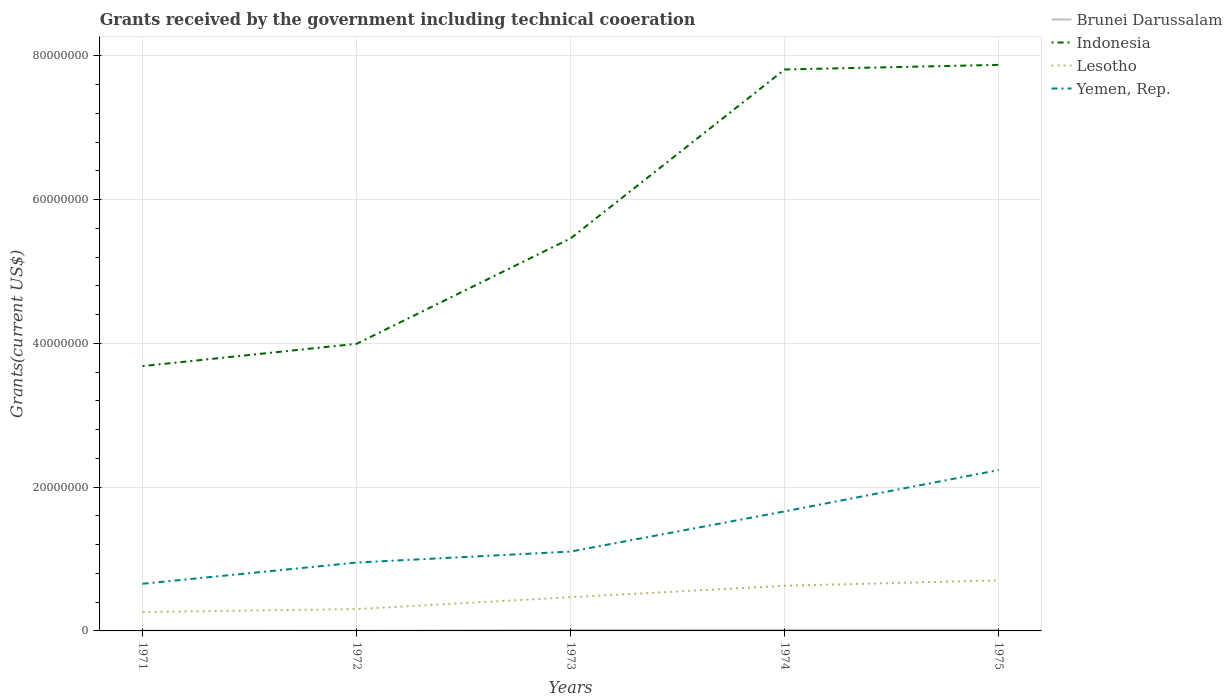How many different coloured lines are there?
Your response must be concise. 4. Does the line corresponding to Lesotho intersect with the line corresponding to Yemen, Rep.?
Provide a succinct answer. No. Is the number of lines equal to the number of legend labels?
Your answer should be compact. Yes. Across all years, what is the maximum total grants received by the government in Yemen, Rep.?
Provide a succinct answer. 6.56e+06. In which year was the total grants received by the government in Indonesia maximum?
Offer a terse response. 1971. What is the total total grants received by the government in Lesotho in the graph?
Your answer should be very brief. -3.24e+06. What is the difference between the highest and the second highest total grants received by the government in Lesotho?
Make the answer very short. 4.41e+06. What is the difference between the highest and the lowest total grants received by the government in Yemen, Rep.?
Ensure brevity in your answer.  2. How many lines are there?
Your answer should be very brief. 4. How many years are there in the graph?
Your answer should be compact. 5. Are the values on the major ticks of Y-axis written in scientific E-notation?
Offer a terse response. No. Does the graph contain any zero values?
Your response must be concise. No. Does the graph contain grids?
Your response must be concise. Yes. How are the legend labels stacked?
Offer a very short reply. Vertical. What is the title of the graph?
Provide a short and direct response. Grants received by the government including technical cooeration. Does "Malta" appear as one of the legend labels in the graph?
Your answer should be very brief. No. What is the label or title of the X-axis?
Offer a terse response. Years. What is the label or title of the Y-axis?
Offer a very short reply. Grants(current US$). What is the Grants(current US$) of Indonesia in 1971?
Ensure brevity in your answer.  3.68e+07. What is the Grants(current US$) of Lesotho in 1971?
Your answer should be very brief. 2.63e+06. What is the Grants(current US$) of Yemen, Rep. in 1971?
Keep it short and to the point. 6.56e+06. What is the Grants(current US$) in Indonesia in 1972?
Ensure brevity in your answer.  3.99e+07. What is the Grants(current US$) in Lesotho in 1972?
Make the answer very short. 3.04e+06. What is the Grants(current US$) in Yemen, Rep. in 1972?
Offer a very short reply. 9.51e+06. What is the Grants(current US$) of Brunei Darussalam in 1973?
Your response must be concise. 1.20e+05. What is the Grants(current US$) of Indonesia in 1973?
Offer a terse response. 5.46e+07. What is the Grants(current US$) in Lesotho in 1973?
Offer a terse response. 4.69e+06. What is the Grants(current US$) in Yemen, Rep. in 1973?
Your answer should be very brief. 1.10e+07. What is the Grants(current US$) in Brunei Darussalam in 1974?
Keep it short and to the point. 1.50e+05. What is the Grants(current US$) of Indonesia in 1974?
Your answer should be compact. 7.81e+07. What is the Grants(current US$) of Lesotho in 1974?
Provide a short and direct response. 6.28e+06. What is the Grants(current US$) in Yemen, Rep. in 1974?
Provide a short and direct response. 1.66e+07. What is the Grants(current US$) in Brunei Darussalam in 1975?
Offer a terse response. 1.40e+05. What is the Grants(current US$) in Indonesia in 1975?
Offer a terse response. 7.87e+07. What is the Grants(current US$) in Lesotho in 1975?
Provide a short and direct response. 7.04e+06. What is the Grants(current US$) of Yemen, Rep. in 1975?
Provide a short and direct response. 2.24e+07. Across all years, what is the maximum Grants(current US$) in Indonesia?
Provide a succinct answer. 7.87e+07. Across all years, what is the maximum Grants(current US$) of Lesotho?
Ensure brevity in your answer.  7.04e+06. Across all years, what is the maximum Grants(current US$) of Yemen, Rep.?
Your answer should be compact. 2.24e+07. Across all years, what is the minimum Grants(current US$) of Brunei Darussalam?
Offer a terse response. 2.00e+04. Across all years, what is the minimum Grants(current US$) in Indonesia?
Provide a succinct answer. 3.68e+07. Across all years, what is the minimum Grants(current US$) in Lesotho?
Keep it short and to the point. 2.63e+06. Across all years, what is the minimum Grants(current US$) of Yemen, Rep.?
Keep it short and to the point. 6.56e+06. What is the total Grants(current US$) in Indonesia in the graph?
Offer a very short reply. 2.88e+08. What is the total Grants(current US$) of Lesotho in the graph?
Your response must be concise. 2.37e+07. What is the total Grants(current US$) of Yemen, Rep. in the graph?
Offer a very short reply. 6.61e+07. What is the difference between the Grants(current US$) in Indonesia in 1971 and that in 1972?
Ensure brevity in your answer.  -3.10e+06. What is the difference between the Grants(current US$) in Lesotho in 1971 and that in 1972?
Provide a succinct answer. -4.10e+05. What is the difference between the Grants(current US$) in Yemen, Rep. in 1971 and that in 1972?
Your answer should be very brief. -2.95e+06. What is the difference between the Grants(current US$) in Indonesia in 1971 and that in 1973?
Your answer should be very brief. -1.78e+07. What is the difference between the Grants(current US$) of Lesotho in 1971 and that in 1973?
Your answer should be very brief. -2.06e+06. What is the difference between the Grants(current US$) in Yemen, Rep. in 1971 and that in 1973?
Give a very brief answer. -4.48e+06. What is the difference between the Grants(current US$) of Indonesia in 1971 and that in 1974?
Give a very brief answer. -4.13e+07. What is the difference between the Grants(current US$) in Lesotho in 1971 and that in 1974?
Offer a terse response. -3.65e+06. What is the difference between the Grants(current US$) of Yemen, Rep. in 1971 and that in 1974?
Provide a succinct answer. -1.01e+07. What is the difference between the Grants(current US$) in Indonesia in 1971 and that in 1975?
Your response must be concise. -4.19e+07. What is the difference between the Grants(current US$) of Lesotho in 1971 and that in 1975?
Give a very brief answer. -4.41e+06. What is the difference between the Grants(current US$) in Yemen, Rep. in 1971 and that in 1975?
Your answer should be very brief. -1.58e+07. What is the difference between the Grants(current US$) of Brunei Darussalam in 1972 and that in 1973?
Your answer should be very brief. -1.00e+05. What is the difference between the Grants(current US$) in Indonesia in 1972 and that in 1973?
Provide a short and direct response. -1.47e+07. What is the difference between the Grants(current US$) of Lesotho in 1972 and that in 1973?
Offer a terse response. -1.65e+06. What is the difference between the Grants(current US$) of Yemen, Rep. in 1972 and that in 1973?
Offer a terse response. -1.53e+06. What is the difference between the Grants(current US$) of Brunei Darussalam in 1972 and that in 1974?
Make the answer very short. -1.30e+05. What is the difference between the Grants(current US$) of Indonesia in 1972 and that in 1974?
Offer a very short reply. -3.82e+07. What is the difference between the Grants(current US$) of Lesotho in 1972 and that in 1974?
Provide a succinct answer. -3.24e+06. What is the difference between the Grants(current US$) in Yemen, Rep. in 1972 and that in 1974?
Give a very brief answer. -7.12e+06. What is the difference between the Grants(current US$) in Brunei Darussalam in 1972 and that in 1975?
Give a very brief answer. -1.20e+05. What is the difference between the Grants(current US$) of Indonesia in 1972 and that in 1975?
Your answer should be compact. -3.88e+07. What is the difference between the Grants(current US$) in Lesotho in 1972 and that in 1975?
Your response must be concise. -4.00e+06. What is the difference between the Grants(current US$) of Yemen, Rep. in 1972 and that in 1975?
Give a very brief answer. -1.29e+07. What is the difference between the Grants(current US$) in Indonesia in 1973 and that in 1974?
Your response must be concise. -2.35e+07. What is the difference between the Grants(current US$) of Lesotho in 1973 and that in 1974?
Make the answer very short. -1.59e+06. What is the difference between the Grants(current US$) of Yemen, Rep. in 1973 and that in 1974?
Provide a succinct answer. -5.59e+06. What is the difference between the Grants(current US$) in Indonesia in 1973 and that in 1975?
Offer a terse response. -2.41e+07. What is the difference between the Grants(current US$) in Lesotho in 1973 and that in 1975?
Provide a short and direct response. -2.35e+06. What is the difference between the Grants(current US$) of Yemen, Rep. in 1973 and that in 1975?
Provide a short and direct response. -1.13e+07. What is the difference between the Grants(current US$) in Indonesia in 1974 and that in 1975?
Your answer should be compact. -6.40e+05. What is the difference between the Grants(current US$) of Lesotho in 1974 and that in 1975?
Your answer should be compact. -7.60e+05. What is the difference between the Grants(current US$) of Yemen, Rep. in 1974 and that in 1975?
Offer a terse response. -5.75e+06. What is the difference between the Grants(current US$) of Brunei Darussalam in 1971 and the Grants(current US$) of Indonesia in 1972?
Keep it short and to the point. -3.99e+07. What is the difference between the Grants(current US$) of Brunei Darussalam in 1971 and the Grants(current US$) of Lesotho in 1972?
Provide a succinct answer. -2.99e+06. What is the difference between the Grants(current US$) in Brunei Darussalam in 1971 and the Grants(current US$) in Yemen, Rep. in 1972?
Your answer should be compact. -9.46e+06. What is the difference between the Grants(current US$) of Indonesia in 1971 and the Grants(current US$) of Lesotho in 1972?
Make the answer very short. 3.38e+07. What is the difference between the Grants(current US$) of Indonesia in 1971 and the Grants(current US$) of Yemen, Rep. in 1972?
Offer a terse response. 2.73e+07. What is the difference between the Grants(current US$) in Lesotho in 1971 and the Grants(current US$) in Yemen, Rep. in 1972?
Provide a short and direct response. -6.88e+06. What is the difference between the Grants(current US$) of Brunei Darussalam in 1971 and the Grants(current US$) of Indonesia in 1973?
Give a very brief answer. -5.46e+07. What is the difference between the Grants(current US$) of Brunei Darussalam in 1971 and the Grants(current US$) of Lesotho in 1973?
Your answer should be very brief. -4.64e+06. What is the difference between the Grants(current US$) in Brunei Darussalam in 1971 and the Grants(current US$) in Yemen, Rep. in 1973?
Keep it short and to the point. -1.10e+07. What is the difference between the Grants(current US$) of Indonesia in 1971 and the Grants(current US$) of Lesotho in 1973?
Offer a very short reply. 3.22e+07. What is the difference between the Grants(current US$) of Indonesia in 1971 and the Grants(current US$) of Yemen, Rep. in 1973?
Provide a short and direct response. 2.58e+07. What is the difference between the Grants(current US$) in Lesotho in 1971 and the Grants(current US$) in Yemen, Rep. in 1973?
Provide a succinct answer. -8.41e+06. What is the difference between the Grants(current US$) in Brunei Darussalam in 1971 and the Grants(current US$) in Indonesia in 1974?
Your answer should be very brief. -7.80e+07. What is the difference between the Grants(current US$) in Brunei Darussalam in 1971 and the Grants(current US$) in Lesotho in 1974?
Give a very brief answer. -6.23e+06. What is the difference between the Grants(current US$) of Brunei Darussalam in 1971 and the Grants(current US$) of Yemen, Rep. in 1974?
Your answer should be compact. -1.66e+07. What is the difference between the Grants(current US$) of Indonesia in 1971 and the Grants(current US$) of Lesotho in 1974?
Make the answer very short. 3.06e+07. What is the difference between the Grants(current US$) of Indonesia in 1971 and the Grants(current US$) of Yemen, Rep. in 1974?
Offer a very short reply. 2.02e+07. What is the difference between the Grants(current US$) of Lesotho in 1971 and the Grants(current US$) of Yemen, Rep. in 1974?
Your answer should be compact. -1.40e+07. What is the difference between the Grants(current US$) in Brunei Darussalam in 1971 and the Grants(current US$) in Indonesia in 1975?
Keep it short and to the point. -7.87e+07. What is the difference between the Grants(current US$) in Brunei Darussalam in 1971 and the Grants(current US$) in Lesotho in 1975?
Your answer should be compact. -6.99e+06. What is the difference between the Grants(current US$) of Brunei Darussalam in 1971 and the Grants(current US$) of Yemen, Rep. in 1975?
Give a very brief answer. -2.23e+07. What is the difference between the Grants(current US$) of Indonesia in 1971 and the Grants(current US$) of Lesotho in 1975?
Your response must be concise. 2.98e+07. What is the difference between the Grants(current US$) in Indonesia in 1971 and the Grants(current US$) in Yemen, Rep. in 1975?
Provide a short and direct response. 1.45e+07. What is the difference between the Grants(current US$) of Lesotho in 1971 and the Grants(current US$) of Yemen, Rep. in 1975?
Your answer should be very brief. -1.98e+07. What is the difference between the Grants(current US$) in Brunei Darussalam in 1972 and the Grants(current US$) in Indonesia in 1973?
Offer a very short reply. -5.46e+07. What is the difference between the Grants(current US$) in Brunei Darussalam in 1972 and the Grants(current US$) in Lesotho in 1973?
Your answer should be very brief. -4.67e+06. What is the difference between the Grants(current US$) in Brunei Darussalam in 1972 and the Grants(current US$) in Yemen, Rep. in 1973?
Offer a terse response. -1.10e+07. What is the difference between the Grants(current US$) of Indonesia in 1972 and the Grants(current US$) of Lesotho in 1973?
Your answer should be very brief. 3.52e+07. What is the difference between the Grants(current US$) of Indonesia in 1972 and the Grants(current US$) of Yemen, Rep. in 1973?
Make the answer very short. 2.89e+07. What is the difference between the Grants(current US$) in Lesotho in 1972 and the Grants(current US$) in Yemen, Rep. in 1973?
Offer a terse response. -8.00e+06. What is the difference between the Grants(current US$) of Brunei Darussalam in 1972 and the Grants(current US$) of Indonesia in 1974?
Your answer should be very brief. -7.81e+07. What is the difference between the Grants(current US$) in Brunei Darussalam in 1972 and the Grants(current US$) in Lesotho in 1974?
Your response must be concise. -6.26e+06. What is the difference between the Grants(current US$) in Brunei Darussalam in 1972 and the Grants(current US$) in Yemen, Rep. in 1974?
Keep it short and to the point. -1.66e+07. What is the difference between the Grants(current US$) in Indonesia in 1972 and the Grants(current US$) in Lesotho in 1974?
Provide a short and direct response. 3.37e+07. What is the difference between the Grants(current US$) of Indonesia in 1972 and the Grants(current US$) of Yemen, Rep. in 1974?
Offer a very short reply. 2.33e+07. What is the difference between the Grants(current US$) in Lesotho in 1972 and the Grants(current US$) in Yemen, Rep. in 1974?
Ensure brevity in your answer.  -1.36e+07. What is the difference between the Grants(current US$) of Brunei Darussalam in 1972 and the Grants(current US$) of Indonesia in 1975?
Your answer should be compact. -7.87e+07. What is the difference between the Grants(current US$) in Brunei Darussalam in 1972 and the Grants(current US$) in Lesotho in 1975?
Offer a terse response. -7.02e+06. What is the difference between the Grants(current US$) of Brunei Darussalam in 1972 and the Grants(current US$) of Yemen, Rep. in 1975?
Offer a very short reply. -2.24e+07. What is the difference between the Grants(current US$) of Indonesia in 1972 and the Grants(current US$) of Lesotho in 1975?
Your answer should be very brief. 3.29e+07. What is the difference between the Grants(current US$) in Indonesia in 1972 and the Grants(current US$) in Yemen, Rep. in 1975?
Your answer should be compact. 1.76e+07. What is the difference between the Grants(current US$) in Lesotho in 1972 and the Grants(current US$) in Yemen, Rep. in 1975?
Offer a very short reply. -1.93e+07. What is the difference between the Grants(current US$) in Brunei Darussalam in 1973 and the Grants(current US$) in Indonesia in 1974?
Give a very brief answer. -7.80e+07. What is the difference between the Grants(current US$) of Brunei Darussalam in 1973 and the Grants(current US$) of Lesotho in 1974?
Keep it short and to the point. -6.16e+06. What is the difference between the Grants(current US$) in Brunei Darussalam in 1973 and the Grants(current US$) in Yemen, Rep. in 1974?
Give a very brief answer. -1.65e+07. What is the difference between the Grants(current US$) in Indonesia in 1973 and the Grants(current US$) in Lesotho in 1974?
Your answer should be compact. 4.83e+07. What is the difference between the Grants(current US$) in Indonesia in 1973 and the Grants(current US$) in Yemen, Rep. in 1974?
Give a very brief answer. 3.80e+07. What is the difference between the Grants(current US$) of Lesotho in 1973 and the Grants(current US$) of Yemen, Rep. in 1974?
Ensure brevity in your answer.  -1.19e+07. What is the difference between the Grants(current US$) of Brunei Darussalam in 1973 and the Grants(current US$) of Indonesia in 1975?
Provide a succinct answer. -7.86e+07. What is the difference between the Grants(current US$) of Brunei Darussalam in 1973 and the Grants(current US$) of Lesotho in 1975?
Provide a short and direct response. -6.92e+06. What is the difference between the Grants(current US$) of Brunei Darussalam in 1973 and the Grants(current US$) of Yemen, Rep. in 1975?
Your answer should be compact. -2.23e+07. What is the difference between the Grants(current US$) of Indonesia in 1973 and the Grants(current US$) of Lesotho in 1975?
Keep it short and to the point. 4.76e+07. What is the difference between the Grants(current US$) of Indonesia in 1973 and the Grants(current US$) of Yemen, Rep. in 1975?
Give a very brief answer. 3.22e+07. What is the difference between the Grants(current US$) of Lesotho in 1973 and the Grants(current US$) of Yemen, Rep. in 1975?
Your response must be concise. -1.77e+07. What is the difference between the Grants(current US$) in Brunei Darussalam in 1974 and the Grants(current US$) in Indonesia in 1975?
Give a very brief answer. -7.86e+07. What is the difference between the Grants(current US$) in Brunei Darussalam in 1974 and the Grants(current US$) in Lesotho in 1975?
Provide a succinct answer. -6.89e+06. What is the difference between the Grants(current US$) in Brunei Darussalam in 1974 and the Grants(current US$) in Yemen, Rep. in 1975?
Provide a succinct answer. -2.22e+07. What is the difference between the Grants(current US$) of Indonesia in 1974 and the Grants(current US$) of Lesotho in 1975?
Keep it short and to the point. 7.11e+07. What is the difference between the Grants(current US$) in Indonesia in 1974 and the Grants(current US$) in Yemen, Rep. in 1975?
Your answer should be very brief. 5.57e+07. What is the difference between the Grants(current US$) of Lesotho in 1974 and the Grants(current US$) of Yemen, Rep. in 1975?
Provide a succinct answer. -1.61e+07. What is the average Grants(current US$) in Brunei Darussalam per year?
Provide a short and direct response. 9.60e+04. What is the average Grants(current US$) of Indonesia per year?
Make the answer very short. 5.76e+07. What is the average Grants(current US$) in Lesotho per year?
Give a very brief answer. 4.74e+06. What is the average Grants(current US$) in Yemen, Rep. per year?
Provide a succinct answer. 1.32e+07. In the year 1971, what is the difference between the Grants(current US$) in Brunei Darussalam and Grants(current US$) in Indonesia?
Provide a short and direct response. -3.68e+07. In the year 1971, what is the difference between the Grants(current US$) in Brunei Darussalam and Grants(current US$) in Lesotho?
Your response must be concise. -2.58e+06. In the year 1971, what is the difference between the Grants(current US$) of Brunei Darussalam and Grants(current US$) of Yemen, Rep.?
Your answer should be very brief. -6.51e+06. In the year 1971, what is the difference between the Grants(current US$) in Indonesia and Grants(current US$) in Lesotho?
Your response must be concise. 3.42e+07. In the year 1971, what is the difference between the Grants(current US$) of Indonesia and Grants(current US$) of Yemen, Rep.?
Your answer should be very brief. 3.03e+07. In the year 1971, what is the difference between the Grants(current US$) in Lesotho and Grants(current US$) in Yemen, Rep.?
Make the answer very short. -3.93e+06. In the year 1972, what is the difference between the Grants(current US$) in Brunei Darussalam and Grants(current US$) in Indonesia?
Give a very brief answer. -3.99e+07. In the year 1972, what is the difference between the Grants(current US$) in Brunei Darussalam and Grants(current US$) in Lesotho?
Provide a succinct answer. -3.02e+06. In the year 1972, what is the difference between the Grants(current US$) of Brunei Darussalam and Grants(current US$) of Yemen, Rep.?
Provide a short and direct response. -9.49e+06. In the year 1972, what is the difference between the Grants(current US$) of Indonesia and Grants(current US$) of Lesotho?
Your answer should be very brief. 3.69e+07. In the year 1972, what is the difference between the Grants(current US$) of Indonesia and Grants(current US$) of Yemen, Rep.?
Your answer should be compact. 3.04e+07. In the year 1972, what is the difference between the Grants(current US$) of Lesotho and Grants(current US$) of Yemen, Rep.?
Your answer should be very brief. -6.47e+06. In the year 1973, what is the difference between the Grants(current US$) of Brunei Darussalam and Grants(current US$) of Indonesia?
Make the answer very short. -5.45e+07. In the year 1973, what is the difference between the Grants(current US$) in Brunei Darussalam and Grants(current US$) in Lesotho?
Provide a succinct answer. -4.57e+06. In the year 1973, what is the difference between the Grants(current US$) of Brunei Darussalam and Grants(current US$) of Yemen, Rep.?
Provide a succinct answer. -1.09e+07. In the year 1973, what is the difference between the Grants(current US$) of Indonesia and Grants(current US$) of Lesotho?
Your response must be concise. 4.99e+07. In the year 1973, what is the difference between the Grants(current US$) of Indonesia and Grants(current US$) of Yemen, Rep.?
Make the answer very short. 4.36e+07. In the year 1973, what is the difference between the Grants(current US$) in Lesotho and Grants(current US$) in Yemen, Rep.?
Make the answer very short. -6.35e+06. In the year 1974, what is the difference between the Grants(current US$) in Brunei Darussalam and Grants(current US$) in Indonesia?
Give a very brief answer. -7.80e+07. In the year 1974, what is the difference between the Grants(current US$) of Brunei Darussalam and Grants(current US$) of Lesotho?
Provide a succinct answer. -6.13e+06. In the year 1974, what is the difference between the Grants(current US$) of Brunei Darussalam and Grants(current US$) of Yemen, Rep.?
Provide a short and direct response. -1.65e+07. In the year 1974, what is the difference between the Grants(current US$) in Indonesia and Grants(current US$) in Lesotho?
Keep it short and to the point. 7.18e+07. In the year 1974, what is the difference between the Grants(current US$) of Indonesia and Grants(current US$) of Yemen, Rep.?
Provide a short and direct response. 6.15e+07. In the year 1974, what is the difference between the Grants(current US$) in Lesotho and Grants(current US$) in Yemen, Rep.?
Your response must be concise. -1.04e+07. In the year 1975, what is the difference between the Grants(current US$) in Brunei Darussalam and Grants(current US$) in Indonesia?
Offer a very short reply. -7.86e+07. In the year 1975, what is the difference between the Grants(current US$) in Brunei Darussalam and Grants(current US$) in Lesotho?
Keep it short and to the point. -6.90e+06. In the year 1975, what is the difference between the Grants(current US$) in Brunei Darussalam and Grants(current US$) in Yemen, Rep.?
Provide a short and direct response. -2.22e+07. In the year 1975, what is the difference between the Grants(current US$) in Indonesia and Grants(current US$) in Lesotho?
Offer a terse response. 7.17e+07. In the year 1975, what is the difference between the Grants(current US$) in Indonesia and Grants(current US$) in Yemen, Rep.?
Ensure brevity in your answer.  5.64e+07. In the year 1975, what is the difference between the Grants(current US$) of Lesotho and Grants(current US$) of Yemen, Rep.?
Offer a terse response. -1.53e+07. What is the ratio of the Grants(current US$) in Brunei Darussalam in 1971 to that in 1972?
Make the answer very short. 2.5. What is the ratio of the Grants(current US$) in Indonesia in 1971 to that in 1972?
Make the answer very short. 0.92. What is the ratio of the Grants(current US$) of Lesotho in 1971 to that in 1972?
Keep it short and to the point. 0.87. What is the ratio of the Grants(current US$) in Yemen, Rep. in 1971 to that in 1972?
Keep it short and to the point. 0.69. What is the ratio of the Grants(current US$) of Brunei Darussalam in 1971 to that in 1973?
Your answer should be compact. 0.42. What is the ratio of the Grants(current US$) in Indonesia in 1971 to that in 1973?
Offer a terse response. 0.67. What is the ratio of the Grants(current US$) of Lesotho in 1971 to that in 1973?
Make the answer very short. 0.56. What is the ratio of the Grants(current US$) in Yemen, Rep. in 1971 to that in 1973?
Give a very brief answer. 0.59. What is the ratio of the Grants(current US$) in Indonesia in 1971 to that in 1974?
Your answer should be compact. 0.47. What is the ratio of the Grants(current US$) of Lesotho in 1971 to that in 1974?
Your answer should be very brief. 0.42. What is the ratio of the Grants(current US$) in Yemen, Rep. in 1971 to that in 1974?
Your response must be concise. 0.39. What is the ratio of the Grants(current US$) in Brunei Darussalam in 1971 to that in 1975?
Keep it short and to the point. 0.36. What is the ratio of the Grants(current US$) of Indonesia in 1971 to that in 1975?
Your response must be concise. 0.47. What is the ratio of the Grants(current US$) of Lesotho in 1971 to that in 1975?
Give a very brief answer. 0.37. What is the ratio of the Grants(current US$) of Yemen, Rep. in 1971 to that in 1975?
Your answer should be compact. 0.29. What is the ratio of the Grants(current US$) of Indonesia in 1972 to that in 1973?
Provide a succinct answer. 0.73. What is the ratio of the Grants(current US$) of Lesotho in 1972 to that in 1973?
Provide a succinct answer. 0.65. What is the ratio of the Grants(current US$) in Yemen, Rep. in 1972 to that in 1973?
Provide a short and direct response. 0.86. What is the ratio of the Grants(current US$) of Brunei Darussalam in 1972 to that in 1974?
Give a very brief answer. 0.13. What is the ratio of the Grants(current US$) of Indonesia in 1972 to that in 1974?
Offer a very short reply. 0.51. What is the ratio of the Grants(current US$) of Lesotho in 1972 to that in 1974?
Keep it short and to the point. 0.48. What is the ratio of the Grants(current US$) in Yemen, Rep. in 1972 to that in 1974?
Give a very brief answer. 0.57. What is the ratio of the Grants(current US$) in Brunei Darussalam in 1972 to that in 1975?
Provide a short and direct response. 0.14. What is the ratio of the Grants(current US$) in Indonesia in 1972 to that in 1975?
Provide a succinct answer. 0.51. What is the ratio of the Grants(current US$) of Lesotho in 1972 to that in 1975?
Provide a short and direct response. 0.43. What is the ratio of the Grants(current US$) in Yemen, Rep. in 1972 to that in 1975?
Your answer should be very brief. 0.42. What is the ratio of the Grants(current US$) of Indonesia in 1973 to that in 1974?
Your answer should be compact. 0.7. What is the ratio of the Grants(current US$) of Lesotho in 1973 to that in 1974?
Give a very brief answer. 0.75. What is the ratio of the Grants(current US$) of Yemen, Rep. in 1973 to that in 1974?
Ensure brevity in your answer.  0.66. What is the ratio of the Grants(current US$) in Brunei Darussalam in 1973 to that in 1975?
Your response must be concise. 0.86. What is the ratio of the Grants(current US$) of Indonesia in 1973 to that in 1975?
Your answer should be compact. 0.69. What is the ratio of the Grants(current US$) in Lesotho in 1973 to that in 1975?
Make the answer very short. 0.67. What is the ratio of the Grants(current US$) of Yemen, Rep. in 1973 to that in 1975?
Your response must be concise. 0.49. What is the ratio of the Grants(current US$) in Brunei Darussalam in 1974 to that in 1975?
Keep it short and to the point. 1.07. What is the ratio of the Grants(current US$) of Indonesia in 1974 to that in 1975?
Provide a short and direct response. 0.99. What is the ratio of the Grants(current US$) of Lesotho in 1974 to that in 1975?
Ensure brevity in your answer.  0.89. What is the ratio of the Grants(current US$) of Yemen, Rep. in 1974 to that in 1975?
Keep it short and to the point. 0.74. What is the difference between the highest and the second highest Grants(current US$) in Brunei Darussalam?
Provide a succinct answer. 10000. What is the difference between the highest and the second highest Grants(current US$) of Indonesia?
Keep it short and to the point. 6.40e+05. What is the difference between the highest and the second highest Grants(current US$) of Lesotho?
Offer a very short reply. 7.60e+05. What is the difference between the highest and the second highest Grants(current US$) in Yemen, Rep.?
Your answer should be very brief. 5.75e+06. What is the difference between the highest and the lowest Grants(current US$) in Indonesia?
Offer a very short reply. 4.19e+07. What is the difference between the highest and the lowest Grants(current US$) in Lesotho?
Provide a short and direct response. 4.41e+06. What is the difference between the highest and the lowest Grants(current US$) in Yemen, Rep.?
Give a very brief answer. 1.58e+07. 